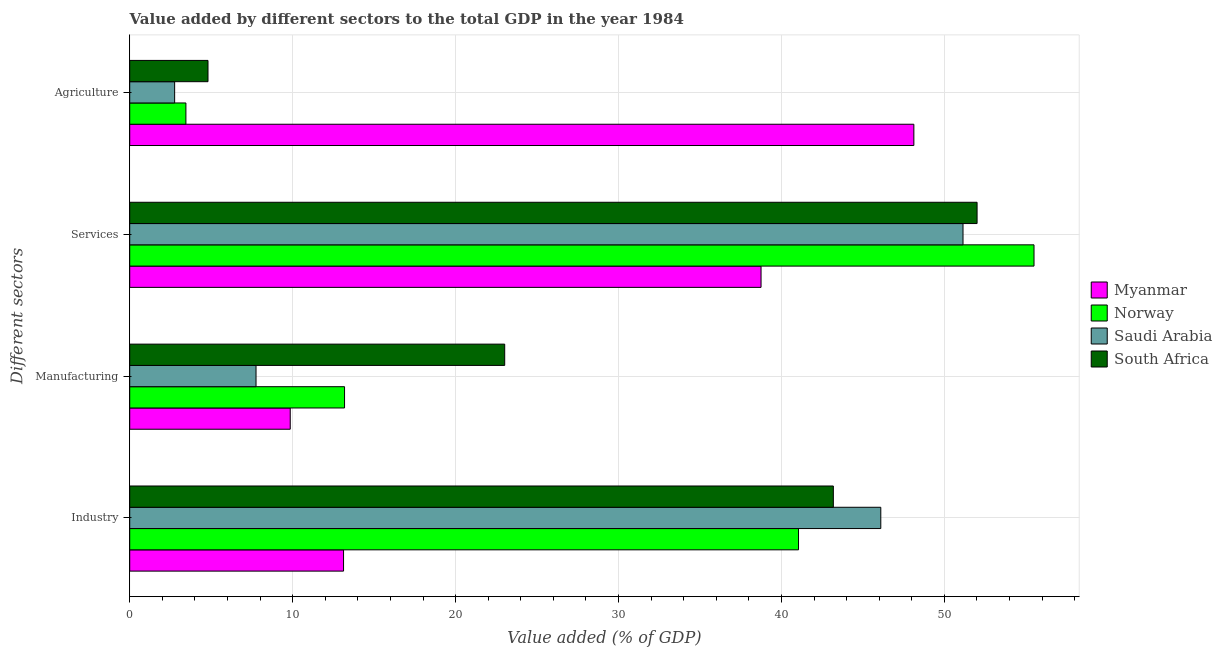How many groups of bars are there?
Your response must be concise. 4. Are the number of bars per tick equal to the number of legend labels?
Keep it short and to the point. Yes. How many bars are there on the 3rd tick from the top?
Your answer should be compact. 4. What is the label of the 4th group of bars from the top?
Your answer should be very brief. Industry. What is the value added by industrial sector in South Africa?
Offer a very short reply. 43.19. Across all countries, what is the maximum value added by agricultural sector?
Your response must be concise. 48.13. Across all countries, what is the minimum value added by agricultural sector?
Provide a succinct answer. 2.76. In which country was the value added by agricultural sector maximum?
Make the answer very short. Myanmar. In which country was the value added by industrial sector minimum?
Provide a succinct answer. Myanmar. What is the total value added by manufacturing sector in the graph?
Give a very brief answer. 53.8. What is the difference between the value added by industrial sector in Saudi Arabia and that in Myanmar?
Your answer should be very brief. 32.97. What is the difference between the value added by services sector in Norway and the value added by industrial sector in Saudi Arabia?
Provide a short and direct response. 9.4. What is the average value added by manufacturing sector per country?
Your answer should be compact. 13.45. What is the difference between the value added by industrial sector and value added by agricultural sector in South Africa?
Your response must be concise. 38.38. In how many countries, is the value added by agricultural sector greater than 42 %?
Make the answer very short. 1. What is the ratio of the value added by agricultural sector in South Africa to that in Myanmar?
Your response must be concise. 0.1. Is the value added by industrial sector in Saudi Arabia less than that in Norway?
Ensure brevity in your answer.  No. What is the difference between the highest and the second highest value added by services sector?
Keep it short and to the point. 3.49. What is the difference between the highest and the lowest value added by industrial sector?
Your answer should be very brief. 32.97. Is the sum of the value added by industrial sector in South Africa and Norway greater than the maximum value added by agricultural sector across all countries?
Keep it short and to the point. Yes. What does the 3rd bar from the top in Industry represents?
Offer a very short reply. Norway. What does the 1st bar from the bottom in Services represents?
Make the answer very short. Myanmar. How many countries are there in the graph?
Your answer should be compact. 4. What is the difference between two consecutive major ticks on the X-axis?
Your answer should be compact. 10. Does the graph contain any zero values?
Give a very brief answer. No. Where does the legend appear in the graph?
Give a very brief answer. Center right. How many legend labels are there?
Ensure brevity in your answer.  4. How are the legend labels stacked?
Provide a short and direct response. Vertical. What is the title of the graph?
Give a very brief answer. Value added by different sectors to the total GDP in the year 1984. Does "OECD members" appear as one of the legend labels in the graph?
Your answer should be very brief. No. What is the label or title of the X-axis?
Ensure brevity in your answer.  Value added (% of GDP). What is the label or title of the Y-axis?
Offer a terse response. Different sectors. What is the Value added (% of GDP) of Myanmar in Industry?
Offer a terse response. 13.12. What is the Value added (% of GDP) of Norway in Industry?
Ensure brevity in your answer.  41.05. What is the Value added (% of GDP) of Saudi Arabia in Industry?
Keep it short and to the point. 46.1. What is the Value added (% of GDP) in South Africa in Industry?
Keep it short and to the point. 43.19. What is the Value added (% of GDP) of Myanmar in Manufacturing?
Offer a very short reply. 9.85. What is the Value added (% of GDP) of Norway in Manufacturing?
Your answer should be very brief. 13.19. What is the Value added (% of GDP) in Saudi Arabia in Manufacturing?
Keep it short and to the point. 7.75. What is the Value added (% of GDP) of South Africa in Manufacturing?
Give a very brief answer. 23.01. What is the Value added (% of GDP) of Myanmar in Services?
Provide a succinct answer. 38.75. What is the Value added (% of GDP) of Norway in Services?
Give a very brief answer. 55.5. What is the Value added (% of GDP) of Saudi Arabia in Services?
Provide a short and direct response. 51.14. What is the Value added (% of GDP) of South Africa in Services?
Provide a succinct answer. 52.01. What is the Value added (% of GDP) of Myanmar in Agriculture?
Your answer should be very brief. 48.13. What is the Value added (% of GDP) in Norway in Agriculture?
Keep it short and to the point. 3.45. What is the Value added (% of GDP) in Saudi Arabia in Agriculture?
Provide a short and direct response. 2.76. What is the Value added (% of GDP) of South Africa in Agriculture?
Make the answer very short. 4.8. Across all Different sectors, what is the maximum Value added (% of GDP) of Myanmar?
Offer a very short reply. 48.13. Across all Different sectors, what is the maximum Value added (% of GDP) in Norway?
Your answer should be compact. 55.5. Across all Different sectors, what is the maximum Value added (% of GDP) in Saudi Arabia?
Offer a terse response. 51.14. Across all Different sectors, what is the maximum Value added (% of GDP) in South Africa?
Give a very brief answer. 52.01. Across all Different sectors, what is the minimum Value added (% of GDP) in Myanmar?
Your answer should be very brief. 9.85. Across all Different sectors, what is the minimum Value added (% of GDP) in Norway?
Make the answer very short. 3.45. Across all Different sectors, what is the minimum Value added (% of GDP) in Saudi Arabia?
Your answer should be compact. 2.76. Across all Different sectors, what is the minimum Value added (% of GDP) in South Africa?
Offer a terse response. 4.8. What is the total Value added (% of GDP) of Myanmar in the graph?
Offer a very short reply. 109.85. What is the total Value added (% of GDP) in Norway in the graph?
Your response must be concise. 113.19. What is the total Value added (% of GDP) of Saudi Arabia in the graph?
Give a very brief answer. 107.75. What is the total Value added (% of GDP) of South Africa in the graph?
Your answer should be very brief. 123.01. What is the difference between the Value added (% of GDP) in Myanmar in Industry and that in Manufacturing?
Offer a terse response. 3.27. What is the difference between the Value added (% of GDP) of Norway in Industry and that in Manufacturing?
Provide a short and direct response. 27.86. What is the difference between the Value added (% of GDP) in Saudi Arabia in Industry and that in Manufacturing?
Your answer should be compact. 38.35. What is the difference between the Value added (% of GDP) of South Africa in Industry and that in Manufacturing?
Offer a terse response. 20.17. What is the difference between the Value added (% of GDP) of Myanmar in Industry and that in Services?
Offer a very short reply. -25.62. What is the difference between the Value added (% of GDP) in Norway in Industry and that in Services?
Ensure brevity in your answer.  -14.45. What is the difference between the Value added (% of GDP) in Saudi Arabia in Industry and that in Services?
Ensure brevity in your answer.  -5.05. What is the difference between the Value added (% of GDP) of South Africa in Industry and that in Services?
Your answer should be compact. -8.82. What is the difference between the Value added (% of GDP) of Myanmar in Industry and that in Agriculture?
Your response must be concise. -35. What is the difference between the Value added (% of GDP) in Norway in Industry and that in Agriculture?
Your response must be concise. 37.6. What is the difference between the Value added (% of GDP) of Saudi Arabia in Industry and that in Agriculture?
Provide a short and direct response. 43.34. What is the difference between the Value added (% of GDP) in South Africa in Industry and that in Agriculture?
Provide a succinct answer. 38.38. What is the difference between the Value added (% of GDP) of Myanmar in Manufacturing and that in Services?
Your response must be concise. -28.9. What is the difference between the Value added (% of GDP) of Norway in Manufacturing and that in Services?
Offer a very short reply. -42.32. What is the difference between the Value added (% of GDP) of Saudi Arabia in Manufacturing and that in Services?
Ensure brevity in your answer.  -43.39. What is the difference between the Value added (% of GDP) of South Africa in Manufacturing and that in Services?
Provide a succinct answer. -28.99. What is the difference between the Value added (% of GDP) of Myanmar in Manufacturing and that in Agriculture?
Offer a terse response. -38.28. What is the difference between the Value added (% of GDP) in Norway in Manufacturing and that in Agriculture?
Your answer should be compact. 9.74. What is the difference between the Value added (% of GDP) in Saudi Arabia in Manufacturing and that in Agriculture?
Offer a terse response. 5. What is the difference between the Value added (% of GDP) in South Africa in Manufacturing and that in Agriculture?
Provide a short and direct response. 18.21. What is the difference between the Value added (% of GDP) in Myanmar in Services and that in Agriculture?
Keep it short and to the point. -9.38. What is the difference between the Value added (% of GDP) in Norway in Services and that in Agriculture?
Ensure brevity in your answer.  52.05. What is the difference between the Value added (% of GDP) of Saudi Arabia in Services and that in Agriculture?
Your response must be concise. 48.39. What is the difference between the Value added (% of GDP) of South Africa in Services and that in Agriculture?
Make the answer very short. 47.2. What is the difference between the Value added (% of GDP) of Myanmar in Industry and the Value added (% of GDP) of Norway in Manufacturing?
Provide a succinct answer. -0.06. What is the difference between the Value added (% of GDP) of Myanmar in Industry and the Value added (% of GDP) of Saudi Arabia in Manufacturing?
Provide a succinct answer. 5.37. What is the difference between the Value added (% of GDP) of Myanmar in Industry and the Value added (% of GDP) of South Africa in Manufacturing?
Ensure brevity in your answer.  -9.89. What is the difference between the Value added (% of GDP) in Norway in Industry and the Value added (% of GDP) in Saudi Arabia in Manufacturing?
Your response must be concise. 33.3. What is the difference between the Value added (% of GDP) of Norway in Industry and the Value added (% of GDP) of South Africa in Manufacturing?
Keep it short and to the point. 18.03. What is the difference between the Value added (% of GDP) in Saudi Arabia in Industry and the Value added (% of GDP) in South Africa in Manufacturing?
Make the answer very short. 23.08. What is the difference between the Value added (% of GDP) of Myanmar in Industry and the Value added (% of GDP) of Norway in Services?
Provide a short and direct response. -42.38. What is the difference between the Value added (% of GDP) in Myanmar in Industry and the Value added (% of GDP) in Saudi Arabia in Services?
Give a very brief answer. -38.02. What is the difference between the Value added (% of GDP) of Myanmar in Industry and the Value added (% of GDP) of South Africa in Services?
Your response must be concise. -38.88. What is the difference between the Value added (% of GDP) in Norway in Industry and the Value added (% of GDP) in Saudi Arabia in Services?
Your response must be concise. -10.1. What is the difference between the Value added (% of GDP) in Norway in Industry and the Value added (% of GDP) in South Africa in Services?
Make the answer very short. -10.96. What is the difference between the Value added (% of GDP) of Saudi Arabia in Industry and the Value added (% of GDP) of South Africa in Services?
Give a very brief answer. -5.91. What is the difference between the Value added (% of GDP) in Myanmar in Industry and the Value added (% of GDP) in Norway in Agriculture?
Provide a short and direct response. 9.68. What is the difference between the Value added (% of GDP) of Myanmar in Industry and the Value added (% of GDP) of Saudi Arabia in Agriculture?
Offer a terse response. 10.37. What is the difference between the Value added (% of GDP) in Myanmar in Industry and the Value added (% of GDP) in South Africa in Agriculture?
Offer a very short reply. 8.32. What is the difference between the Value added (% of GDP) in Norway in Industry and the Value added (% of GDP) in Saudi Arabia in Agriculture?
Give a very brief answer. 38.29. What is the difference between the Value added (% of GDP) of Norway in Industry and the Value added (% of GDP) of South Africa in Agriculture?
Your answer should be very brief. 36.24. What is the difference between the Value added (% of GDP) in Saudi Arabia in Industry and the Value added (% of GDP) in South Africa in Agriculture?
Offer a terse response. 41.29. What is the difference between the Value added (% of GDP) of Myanmar in Manufacturing and the Value added (% of GDP) of Norway in Services?
Your response must be concise. -45.65. What is the difference between the Value added (% of GDP) of Myanmar in Manufacturing and the Value added (% of GDP) of Saudi Arabia in Services?
Provide a succinct answer. -41.29. What is the difference between the Value added (% of GDP) of Myanmar in Manufacturing and the Value added (% of GDP) of South Africa in Services?
Provide a short and direct response. -42.16. What is the difference between the Value added (% of GDP) in Norway in Manufacturing and the Value added (% of GDP) in Saudi Arabia in Services?
Ensure brevity in your answer.  -37.96. What is the difference between the Value added (% of GDP) in Norway in Manufacturing and the Value added (% of GDP) in South Africa in Services?
Give a very brief answer. -38.82. What is the difference between the Value added (% of GDP) of Saudi Arabia in Manufacturing and the Value added (% of GDP) of South Africa in Services?
Ensure brevity in your answer.  -44.26. What is the difference between the Value added (% of GDP) in Myanmar in Manufacturing and the Value added (% of GDP) in Norway in Agriculture?
Your answer should be compact. 6.4. What is the difference between the Value added (% of GDP) of Myanmar in Manufacturing and the Value added (% of GDP) of Saudi Arabia in Agriculture?
Provide a succinct answer. 7.09. What is the difference between the Value added (% of GDP) of Myanmar in Manufacturing and the Value added (% of GDP) of South Africa in Agriculture?
Make the answer very short. 5.05. What is the difference between the Value added (% of GDP) of Norway in Manufacturing and the Value added (% of GDP) of Saudi Arabia in Agriculture?
Your response must be concise. 10.43. What is the difference between the Value added (% of GDP) in Norway in Manufacturing and the Value added (% of GDP) in South Africa in Agriculture?
Your answer should be very brief. 8.38. What is the difference between the Value added (% of GDP) of Saudi Arabia in Manufacturing and the Value added (% of GDP) of South Africa in Agriculture?
Make the answer very short. 2.95. What is the difference between the Value added (% of GDP) in Myanmar in Services and the Value added (% of GDP) in Norway in Agriculture?
Keep it short and to the point. 35.3. What is the difference between the Value added (% of GDP) in Myanmar in Services and the Value added (% of GDP) in Saudi Arabia in Agriculture?
Your response must be concise. 35.99. What is the difference between the Value added (% of GDP) in Myanmar in Services and the Value added (% of GDP) in South Africa in Agriculture?
Make the answer very short. 33.94. What is the difference between the Value added (% of GDP) in Norway in Services and the Value added (% of GDP) in Saudi Arabia in Agriculture?
Give a very brief answer. 52.75. What is the difference between the Value added (% of GDP) in Norway in Services and the Value added (% of GDP) in South Africa in Agriculture?
Your answer should be very brief. 50.7. What is the difference between the Value added (% of GDP) in Saudi Arabia in Services and the Value added (% of GDP) in South Africa in Agriculture?
Your response must be concise. 46.34. What is the average Value added (% of GDP) of Myanmar per Different sectors?
Offer a very short reply. 27.46. What is the average Value added (% of GDP) of Norway per Different sectors?
Your response must be concise. 28.3. What is the average Value added (% of GDP) of Saudi Arabia per Different sectors?
Make the answer very short. 26.94. What is the average Value added (% of GDP) in South Africa per Different sectors?
Your response must be concise. 30.75. What is the difference between the Value added (% of GDP) in Myanmar and Value added (% of GDP) in Norway in Industry?
Offer a very short reply. -27.92. What is the difference between the Value added (% of GDP) in Myanmar and Value added (% of GDP) in Saudi Arabia in Industry?
Make the answer very short. -32.97. What is the difference between the Value added (% of GDP) in Myanmar and Value added (% of GDP) in South Africa in Industry?
Ensure brevity in your answer.  -30.06. What is the difference between the Value added (% of GDP) in Norway and Value added (% of GDP) in Saudi Arabia in Industry?
Give a very brief answer. -5.05. What is the difference between the Value added (% of GDP) in Norway and Value added (% of GDP) in South Africa in Industry?
Your response must be concise. -2.14. What is the difference between the Value added (% of GDP) of Saudi Arabia and Value added (% of GDP) of South Africa in Industry?
Ensure brevity in your answer.  2.91. What is the difference between the Value added (% of GDP) of Myanmar and Value added (% of GDP) of Norway in Manufacturing?
Your answer should be compact. -3.33. What is the difference between the Value added (% of GDP) of Myanmar and Value added (% of GDP) of Saudi Arabia in Manufacturing?
Make the answer very short. 2.1. What is the difference between the Value added (% of GDP) in Myanmar and Value added (% of GDP) in South Africa in Manufacturing?
Offer a very short reply. -13.16. What is the difference between the Value added (% of GDP) in Norway and Value added (% of GDP) in Saudi Arabia in Manufacturing?
Provide a short and direct response. 5.43. What is the difference between the Value added (% of GDP) of Norway and Value added (% of GDP) of South Africa in Manufacturing?
Provide a succinct answer. -9.83. What is the difference between the Value added (% of GDP) of Saudi Arabia and Value added (% of GDP) of South Africa in Manufacturing?
Your answer should be compact. -15.26. What is the difference between the Value added (% of GDP) of Myanmar and Value added (% of GDP) of Norway in Services?
Offer a terse response. -16.75. What is the difference between the Value added (% of GDP) in Myanmar and Value added (% of GDP) in Saudi Arabia in Services?
Your response must be concise. -12.4. What is the difference between the Value added (% of GDP) of Myanmar and Value added (% of GDP) of South Africa in Services?
Your answer should be compact. -13.26. What is the difference between the Value added (% of GDP) of Norway and Value added (% of GDP) of Saudi Arabia in Services?
Provide a short and direct response. 4.36. What is the difference between the Value added (% of GDP) of Norway and Value added (% of GDP) of South Africa in Services?
Your answer should be very brief. 3.49. What is the difference between the Value added (% of GDP) in Saudi Arabia and Value added (% of GDP) in South Africa in Services?
Provide a short and direct response. -0.86. What is the difference between the Value added (% of GDP) of Myanmar and Value added (% of GDP) of Norway in Agriculture?
Ensure brevity in your answer.  44.68. What is the difference between the Value added (% of GDP) of Myanmar and Value added (% of GDP) of Saudi Arabia in Agriculture?
Give a very brief answer. 45.37. What is the difference between the Value added (% of GDP) in Myanmar and Value added (% of GDP) in South Africa in Agriculture?
Provide a short and direct response. 43.32. What is the difference between the Value added (% of GDP) in Norway and Value added (% of GDP) in Saudi Arabia in Agriculture?
Ensure brevity in your answer.  0.69. What is the difference between the Value added (% of GDP) of Norway and Value added (% of GDP) of South Africa in Agriculture?
Your answer should be compact. -1.36. What is the difference between the Value added (% of GDP) in Saudi Arabia and Value added (% of GDP) in South Africa in Agriculture?
Provide a succinct answer. -2.05. What is the ratio of the Value added (% of GDP) in Myanmar in Industry to that in Manufacturing?
Offer a terse response. 1.33. What is the ratio of the Value added (% of GDP) in Norway in Industry to that in Manufacturing?
Your response must be concise. 3.11. What is the ratio of the Value added (% of GDP) in Saudi Arabia in Industry to that in Manufacturing?
Your response must be concise. 5.95. What is the ratio of the Value added (% of GDP) in South Africa in Industry to that in Manufacturing?
Give a very brief answer. 1.88. What is the ratio of the Value added (% of GDP) in Myanmar in Industry to that in Services?
Make the answer very short. 0.34. What is the ratio of the Value added (% of GDP) in Norway in Industry to that in Services?
Give a very brief answer. 0.74. What is the ratio of the Value added (% of GDP) of Saudi Arabia in Industry to that in Services?
Keep it short and to the point. 0.9. What is the ratio of the Value added (% of GDP) in South Africa in Industry to that in Services?
Give a very brief answer. 0.83. What is the ratio of the Value added (% of GDP) of Myanmar in Industry to that in Agriculture?
Offer a terse response. 0.27. What is the ratio of the Value added (% of GDP) in Norway in Industry to that in Agriculture?
Your answer should be compact. 11.9. What is the ratio of the Value added (% of GDP) in Saudi Arabia in Industry to that in Agriculture?
Ensure brevity in your answer.  16.72. What is the ratio of the Value added (% of GDP) of South Africa in Industry to that in Agriculture?
Give a very brief answer. 8.99. What is the ratio of the Value added (% of GDP) in Myanmar in Manufacturing to that in Services?
Ensure brevity in your answer.  0.25. What is the ratio of the Value added (% of GDP) in Norway in Manufacturing to that in Services?
Your answer should be very brief. 0.24. What is the ratio of the Value added (% of GDP) in Saudi Arabia in Manufacturing to that in Services?
Your answer should be very brief. 0.15. What is the ratio of the Value added (% of GDP) in South Africa in Manufacturing to that in Services?
Ensure brevity in your answer.  0.44. What is the ratio of the Value added (% of GDP) in Myanmar in Manufacturing to that in Agriculture?
Your response must be concise. 0.2. What is the ratio of the Value added (% of GDP) in Norway in Manufacturing to that in Agriculture?
Make the answer very short. 3.82. What is the ratio of the Value added (% of GDP) of Saudi Arabia in Manufacturing to that in Agriculture?
Ensure brevity in your answer.  2.81. What is the ratio of the Value added (% of GDP) in South Africa in Manufacturing to that in Agriculture?
Your answer should be very brief. 4.79. What is the ratio of the Value added (% of GDP) of Myanmar in Services to that in Agriculture?
Provide a succinct answer. 0.81. What is the ratio of the Value added (% of GDP) in Norway in Services to that in Agriculture?
Your answer should be compact. 16.09. What is the ratio of the Value added (% of GDP) of Saudi Arabia in Services to that in Agriculture?
Offer a very short reply. 18.55. What is the ratio of the Value added (% of GDP) in South Africa in Services to that in Agriculture?
Make the answer very short. 10.82. What is the difference between the highest and the second highest Value added (% of GDP) in Myanmar?
Keep it short and to the point. 9.38. What is the difference between the highest and the second highest Value added (% of GDP) of Norway?
Your answer should be very brief. 14.45. What is the difference between the highest and the second highest Value added (% of GDP) of Saudi Arabia?
Make the answer very short. 5.05. What is the difference between the highest and the second highest Value added (% of GDP) of South Africa?
Keep it short and to the point. 8.82. What is the difference between the highest and the lowest Value added (% of GDP) in Myanmar?
Your answer should be very brief. 38.28. What is the difference between the highest and the lowest Value added (% of GDP) in Norway?
Provide a succinct answer. 52.05. What is the difference between the highest and the lowest Value added (% of GDP) of Saudi Arabia?
Make the answer very short. 48.39. What is the difference between the highest and the lowest Value added (% of GDP) in South Africa?
Offer a very short reply. 47.2. 